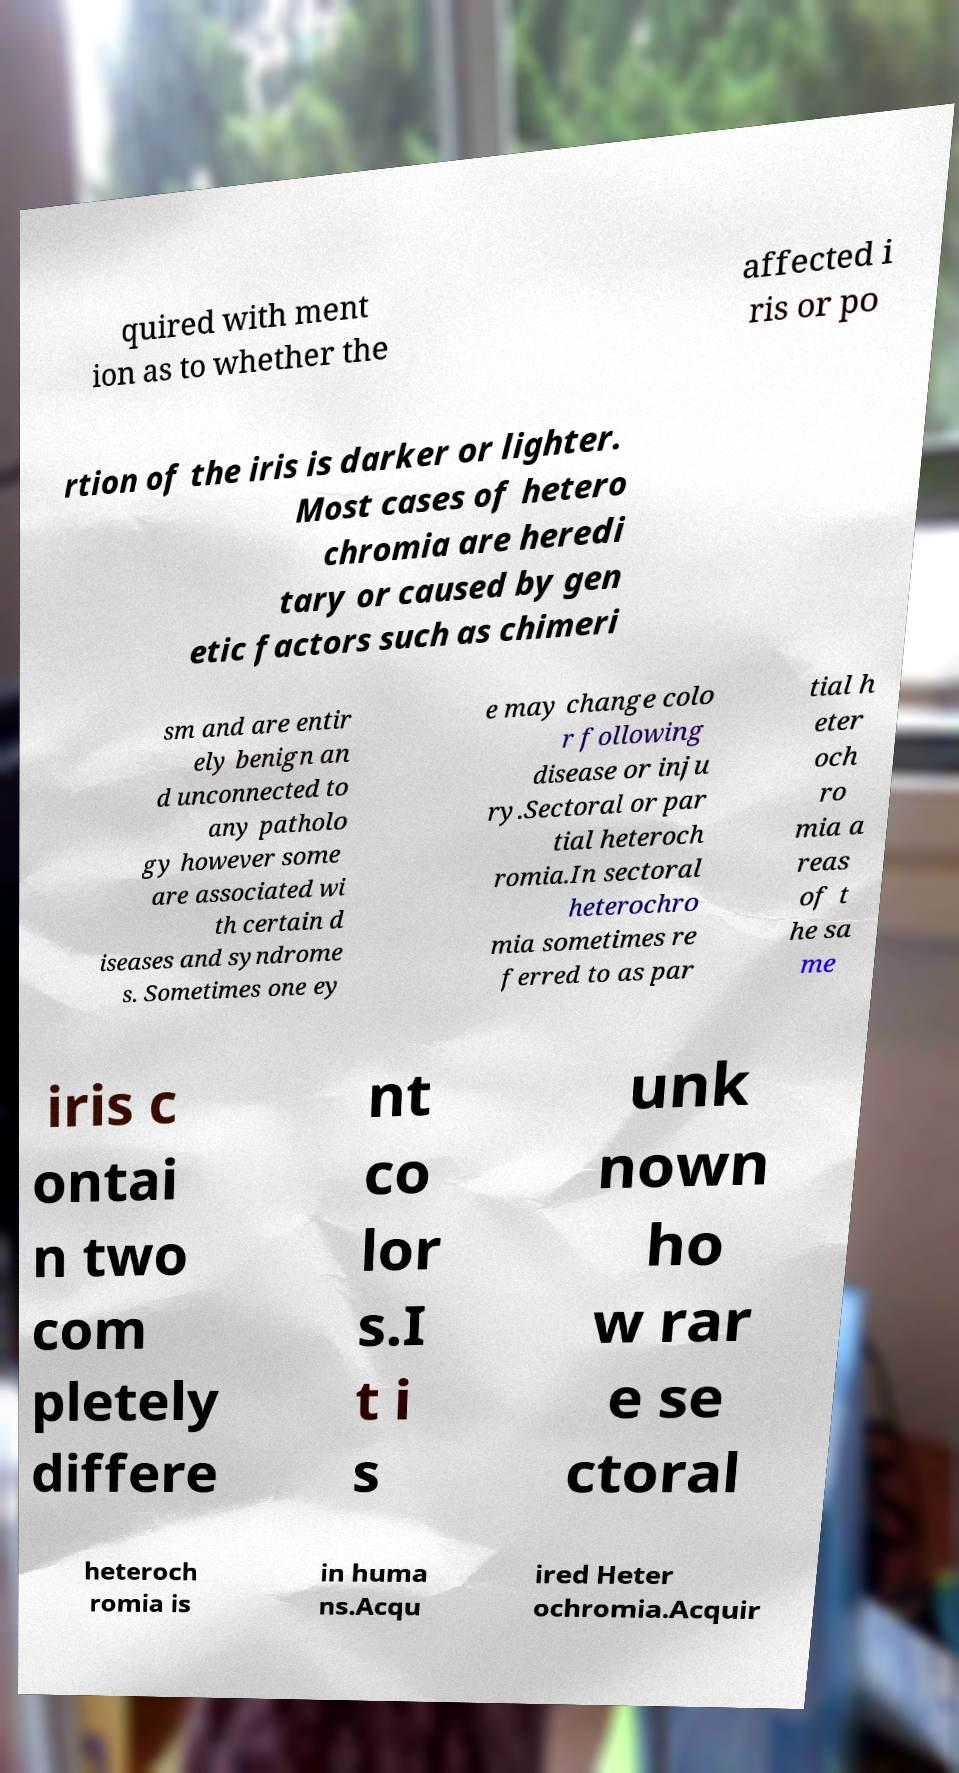Can you accurately transcribe the text from the provided image for me? quired with ment ion as to whether the affected i ris or po rtion of the iris is darker or lighter. Most cases of hetero chromia are heredi tary or caused by gen etic factors such as chimeri sm and are entir ely benign an d unconnected to any patholo gy however some are associated wi th certain d iseases and syndrome s. Sometimes one ey e may change colo r following disease or inju ry.Sectoral or par tial heteroch romia.In sectoral heterochro mia sometimes re ferred to as par tial h eter och ro mia a reas of t he sa me iris c ontai n two com pletely differe nt co lor s.I t i s unk nown ho w rar e se ctoral heteroch romia is in huma ns.Acqu ired Heter ochromia.Acquir 